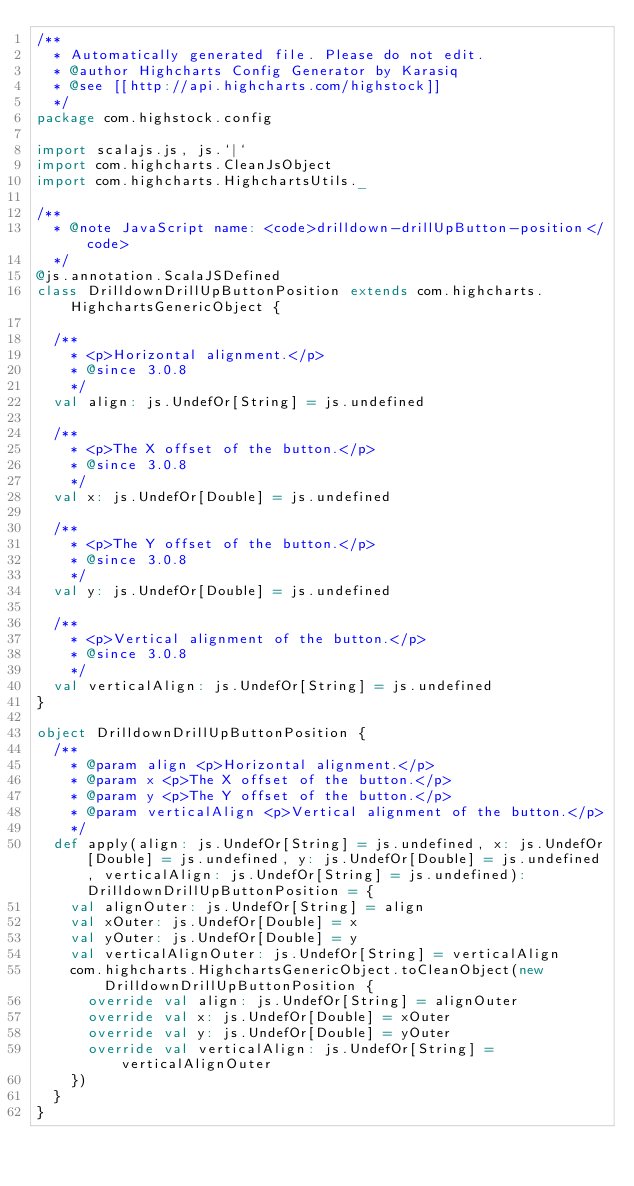<code> <loc_0><loc_0><loc_500><loc_500><_Scala_>/**
  * Automatically generated file. Please do not edit.
  * @author Highcharts Config Generator by Karasiq
  * @see [[http://api.highcharts.com/highstock]]
  */
package com.highstock.config

import scalajs.js, js.`|`
import com.highcharts.CleanJsObject
import com.highcharts.HighchartsUtils._

/**
  * @note JavaScript name: <code>drilldown-drillUpButton-position</code>
  */
@js.annotation.ScalaJSDefined
class DrilldownDrillUpButtonPosition extends com.highcharts.HighchartsGenericObject {

  /**
    * <p>Horizontal alignment.</p>
    * @since 3.0.8
    */
  val align: js.UndefOr[String] = js.undefined

  /**
    * <p>The X offset of the button.</p>
    * @since 3.0.8
    */
  val x: js.UndefOr[Double] = js.undefined

  /**
    * <p>The Y offset of the button.</p>
    * @since 3.0.8
    */
  val y: js.UndefOr[Double] = js.undefined

  /**
    * <p>Vertical alignment of the button.</p>
    * @since 3.0.8
    */
  val verticalAlign: js.UndefOr[String] = js.undefined
}

object DrilldownDrillUpButtonPosition {
  /**
    * @param align <p>Horizontal alignment.</p>
    * @param x <p>The X offset of the button.</p>
    * @param y <p>The Y offset of the button.</p>
    * @param verticalAlign <p>Vertical alignment of the button.</p>
    */
  def apply(align: js.UndefOr[String] = js.undefined, x: js.UndefOr[Double] = js.undefined, y: js.UndefOr[Double] = js.undefined, verticalAlign: js.UndefOr[String] = js.undefined): DrilldownDrillUpButtonPosition = {
    val alignOuter: js.UndefOr[String] = align
    val xOuter: js.UndefOr[Double] = x
    val yOuter: js.UndefOr[Double] = y
    val verticalAlignOuter: js.UndefOr[String] = verticalAlign
    com.highcharts.HighchartsGenericObject.toCleanObject(new DrilldownDrillUpButtonPosition {
      override val align: js.UndefOr[String] = alignOuter
      override val x: js.UndefOr[Double] = xOuter
      override val y: js.UndefOr[Double] = yOuter
      override val verticalAlign: js.UndefOr[String] = verticalAlignOuter
    })
  }
}
</code> 